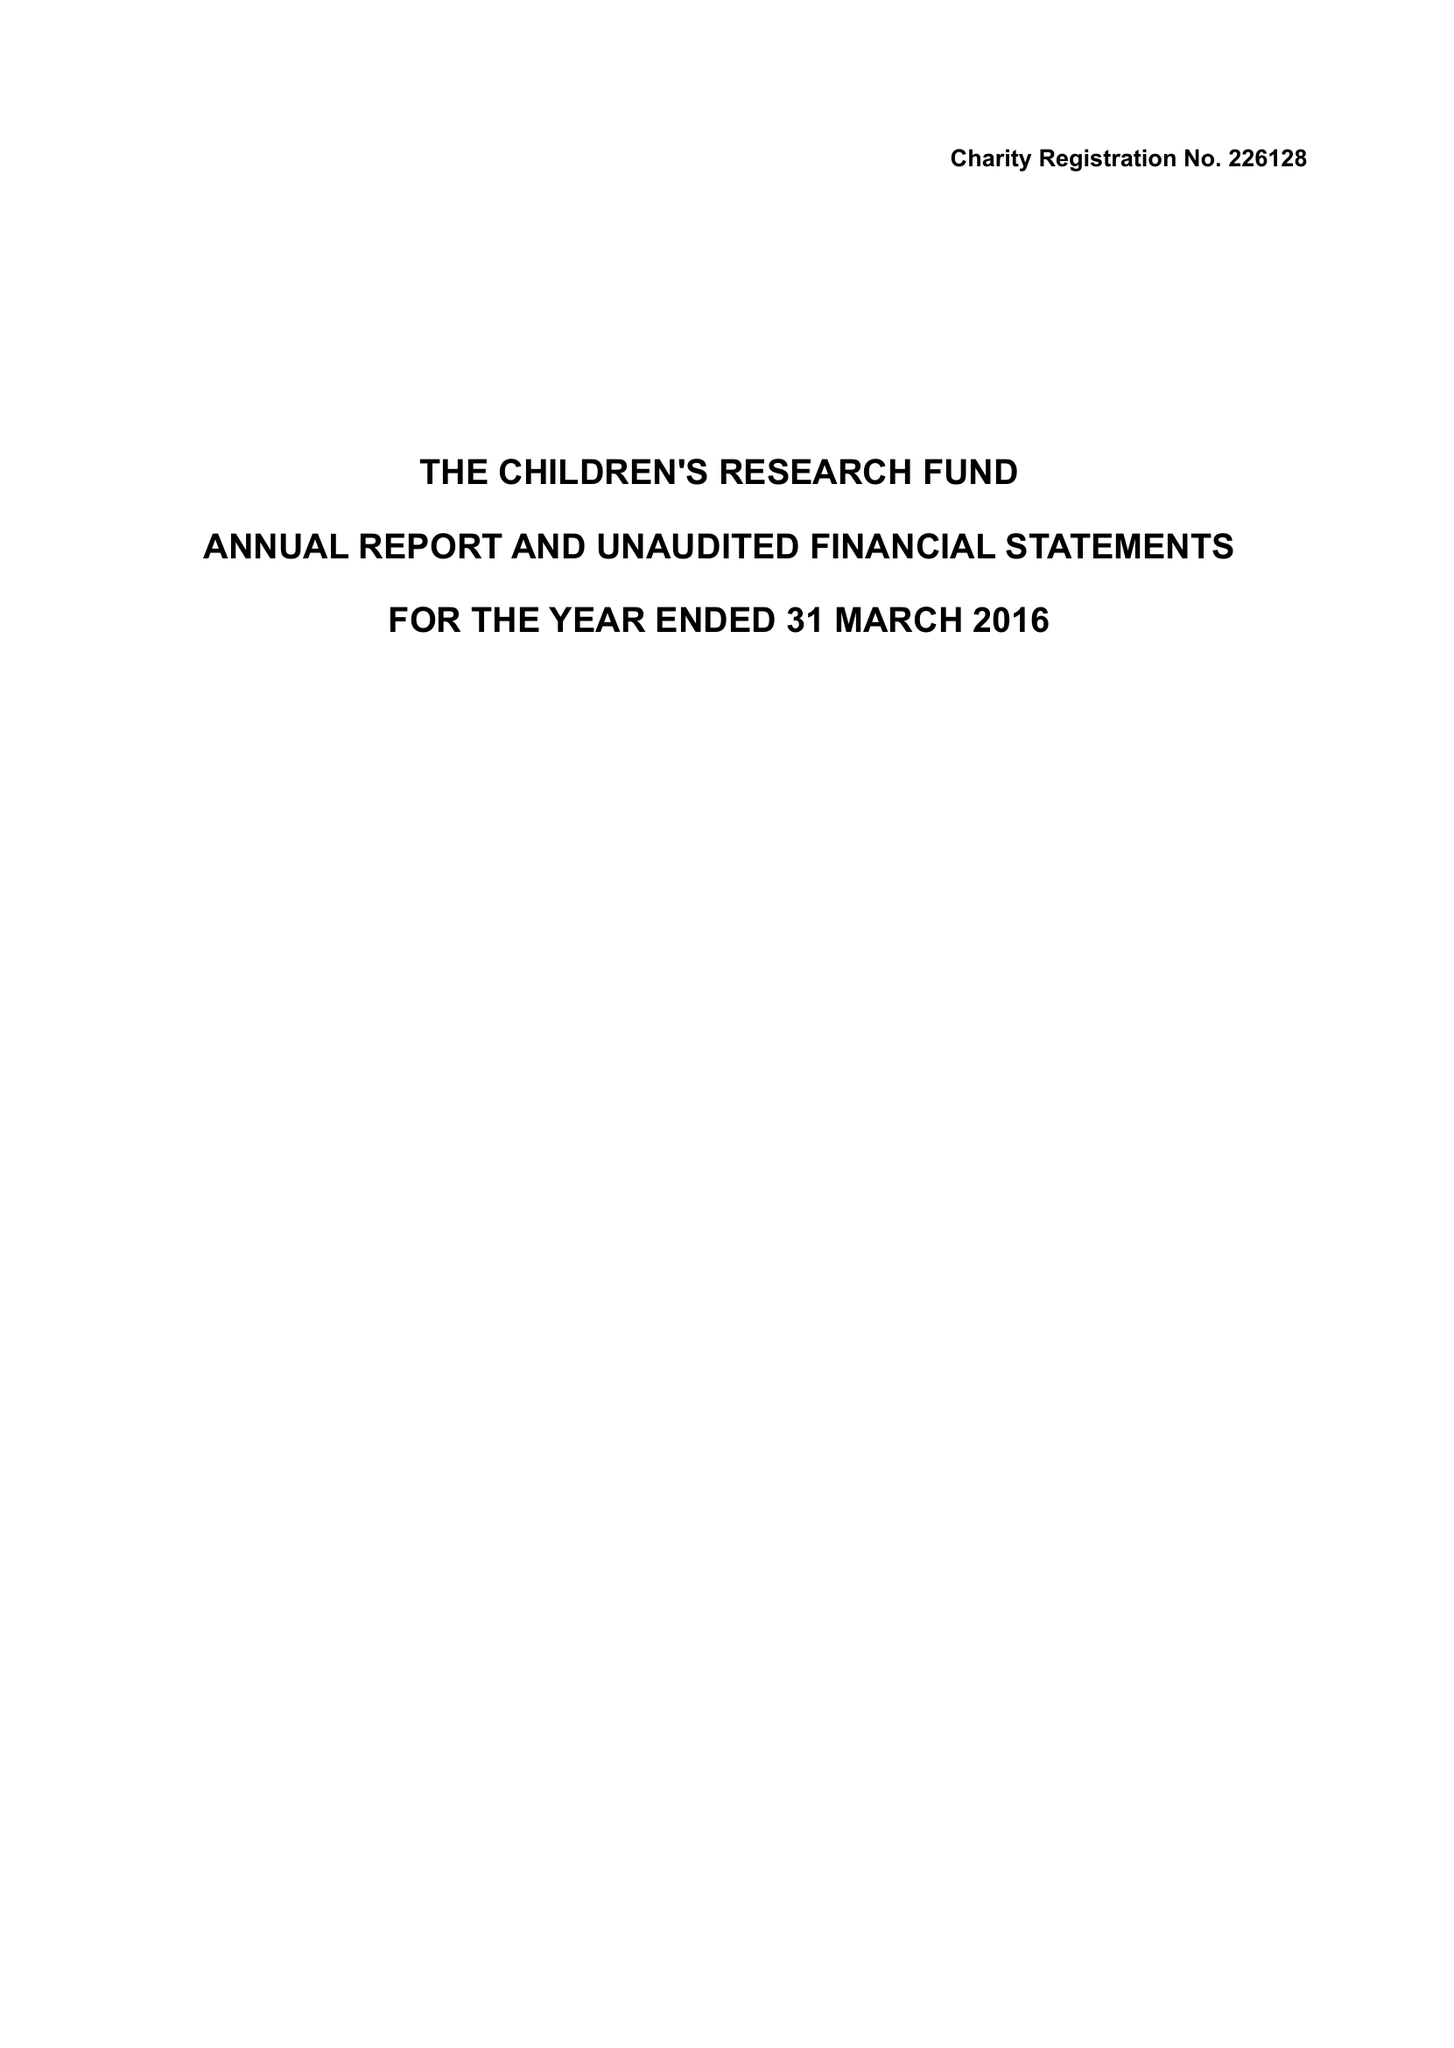What is the value for the spending_annually_in_british_pounds?
Answer the question using a single word or phrase. 6773.00 